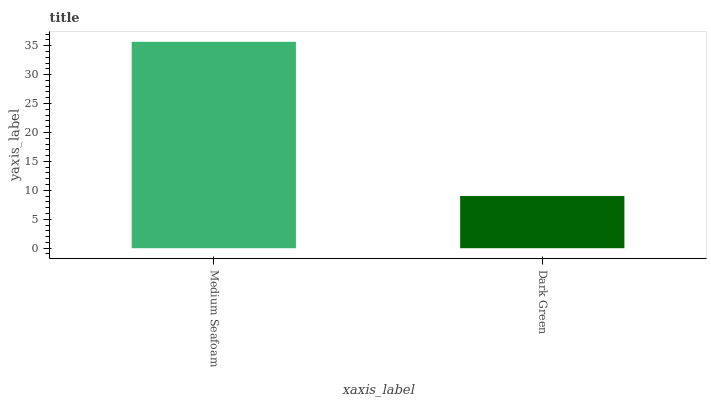Is Dark Green the minimum?
Answer yes or no. Yes. Is Medium Seafoam the maximum?
Answer yes or no. Yes. Is Dark Green the maximum?
Answer yes or no. No. Is Medium Seafoam greater than Dark Green?
Answer yes or no. Yes. Is Dark Green less than Medium Seafoam?
Answer yes or no. Yes. Is Dark Green greater than Medium Seafoam?
Answer yes or no. No. Is Medium Seafoam less than Dark Green?
Answer yes or no. No. Is Medium Seafoam the high median?
Answer yes or no. Yes. Is Dark Green the low median?
Answer yes or no. Yes. Is Dark Green the high median?
Answer yes or no. No. Is Medium Seafoam the low median?
Answer yes or no. No. 